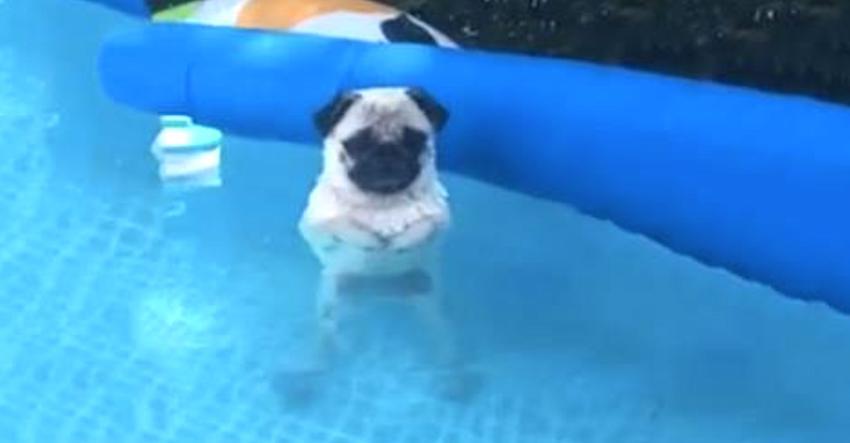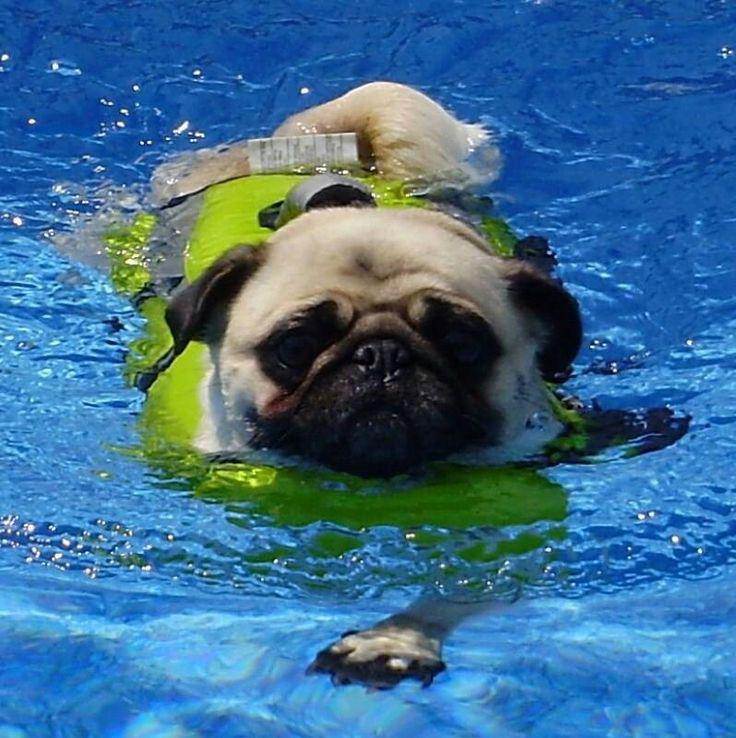The first image is the image on the left, the second image is the image on the right. For the images displayed, is the sentence "A pug wearing a yellowish life vest swims toward the camera." factually correct? Answer yes or no. Yes. The first image is the image on the left, the second image is the image on the right. Examine the images to the left and right. Is the description "Two pug dogs are seen in a swimming pool, one of them riding above the water on an inflatable flotation device, while the other is in the water swimming." accurate? Answer yes or no. No. 